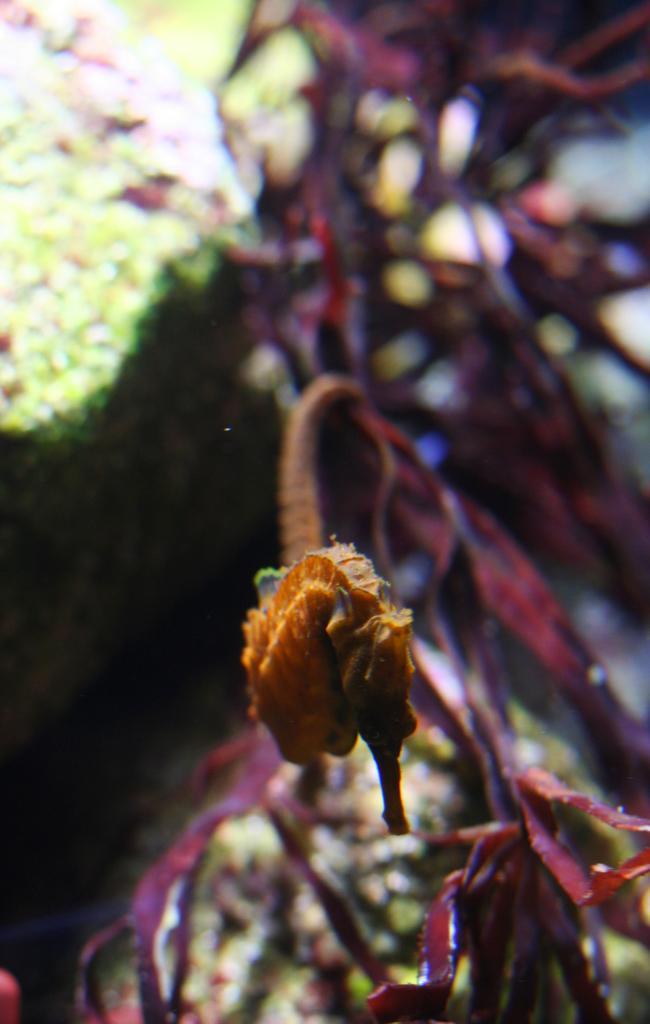Can you describe this image briefly? In the foreground of this image, there is a seahorse under the water. In the background, there are sea plants. 